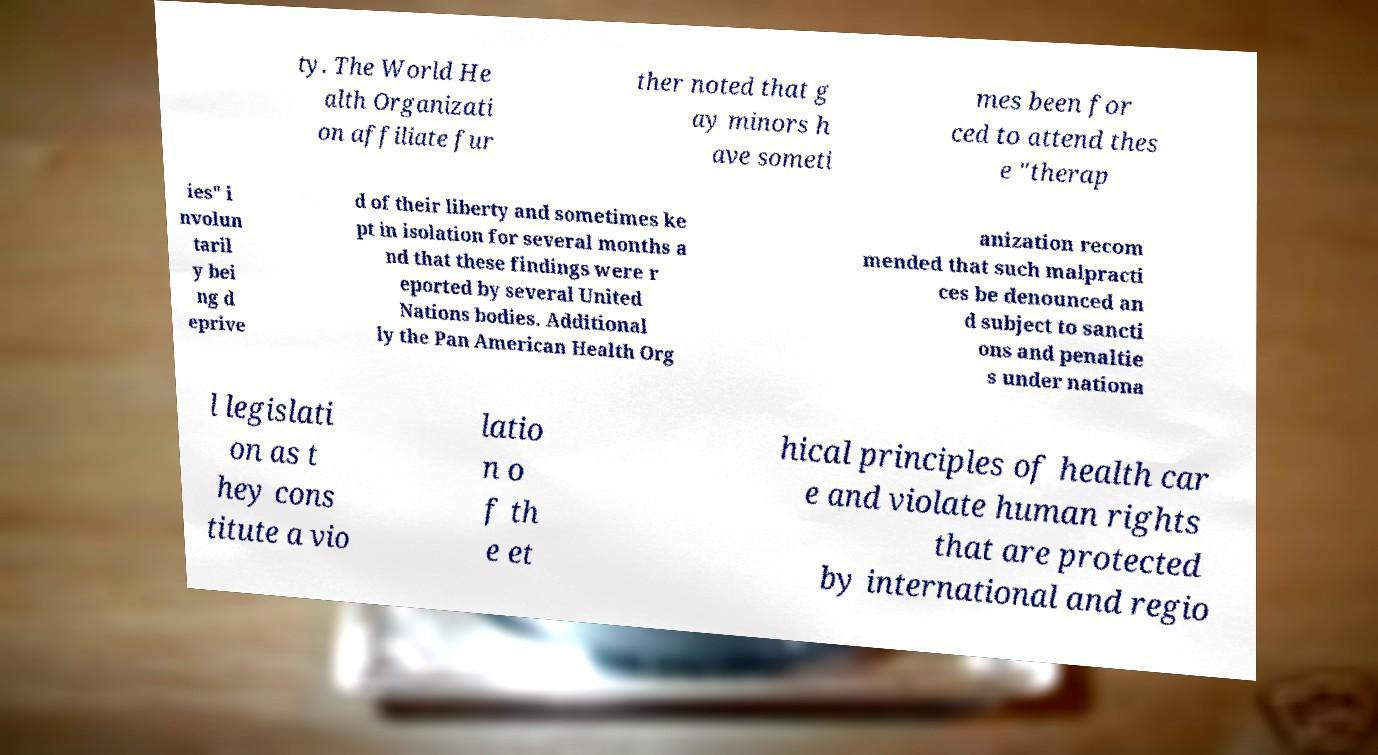There's text embedded in this image that I need extracted. Can you transcribe it verbatim? ty. The World He alth Organizati on affiliate fur ther noted that g ay minors h ave someti mes been for ced to attend thes e "therap ies" i nvolun taril y bei ng d eprive d of their liberty and sometimes ke pt in isolation for several months a nd that these findings were r eported by several United Nations bodies. Additional ly the Pan American Health Org anization recom mended that such malpracti ces be denounced an d subject to sancti ons and penaltie s under nationa l legislati on as t hey cons titute a vio latio n o f th e et hical principles of health car e and violate human rights that are protected by international and regio 